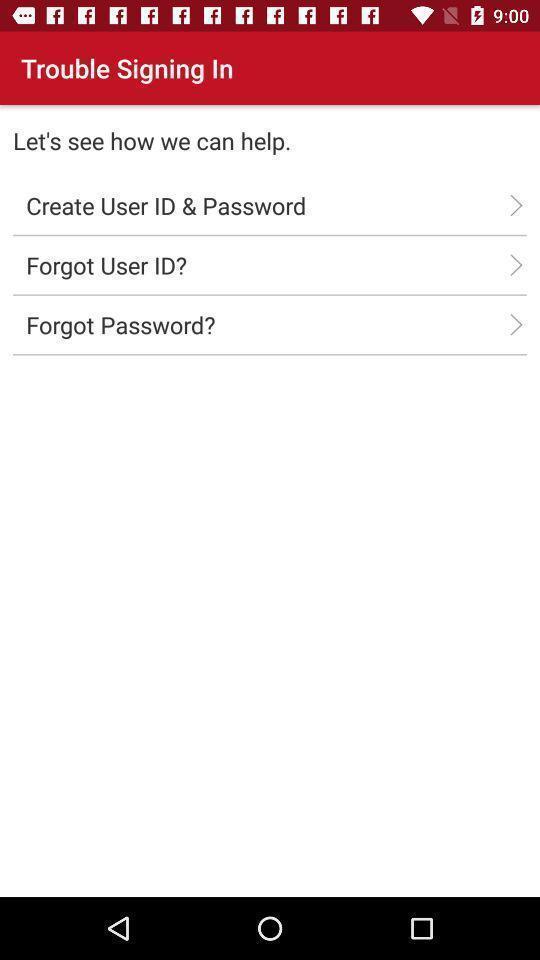Give me a narrative description of this picture. Sign-in page of a social app. 